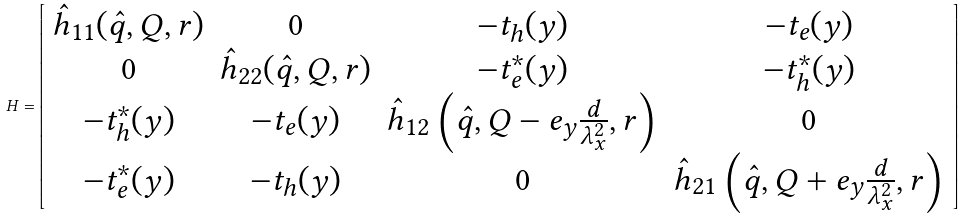Convert formula to latex. <formula><loc_0><loc_0><loc_500><loc_500>H = \left [ \begin{array} { c c c c } \hat { h } _ { 1 1 } ( { \hat { q } } , { Q } , { r } ) & 0 & - t _ { h } ( y ) & - t _ { e } ( y ) \\ 0 & \hat { h } _ { 2 2 } ( { \hat { q } } , { Q } , { r } ) & - t _ { e } ^ { * } ( y ) & - t _ { h } ^ { * } ( y ) \\ - t _ { h } ^ { * } ( y ) & - t _ { e } ( y ) & \hat { h } _ { 1 2 } \left ( { \hat { q } } , { Q } - { e } _ { y } \frac { d } { \lambda _ { x } ^ { 2 } } , { r } \right ) & 0 \\ - t _ { e } ^ { * } ( y ) & - t _ { h } ( y ) & 0 & \hat { h } _ { 2 1 } \left ( { \hat { q } } , { Q } + { e } _ { y } \frac { d } { \lambda _ { x } ^ { 2 } } , { r } \right ) \end{array} \right ]</formula> 